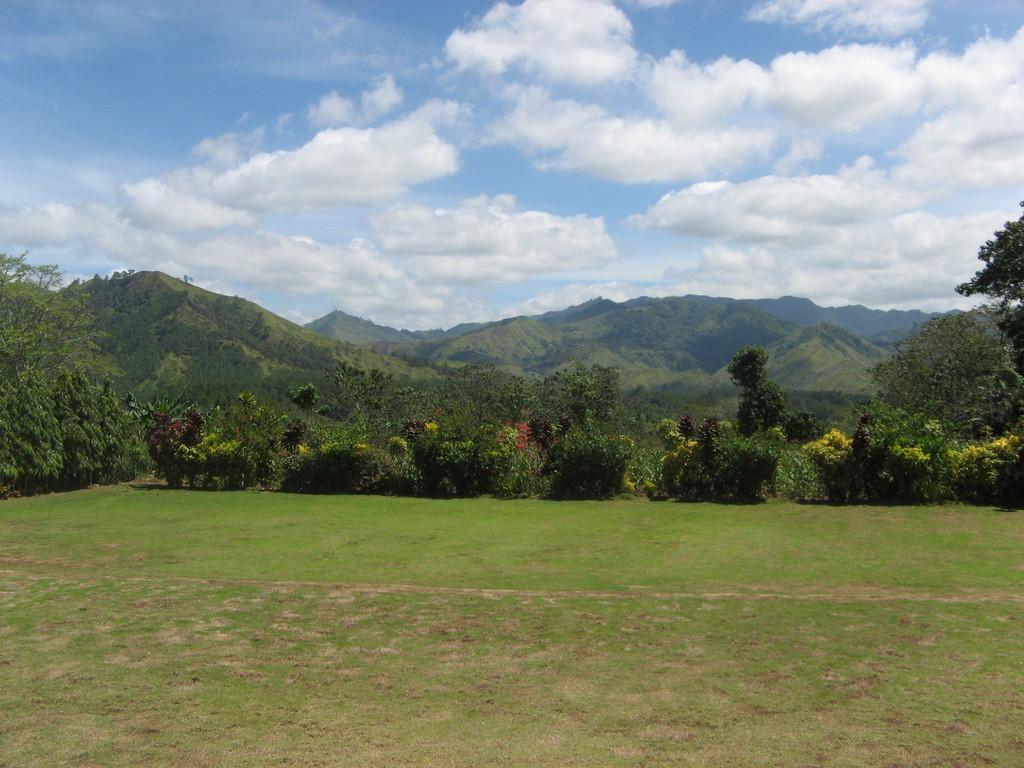In one or two sentences, can you explain what this image depicts? In this image there are grass, trees, plants, mountains and the sky. 